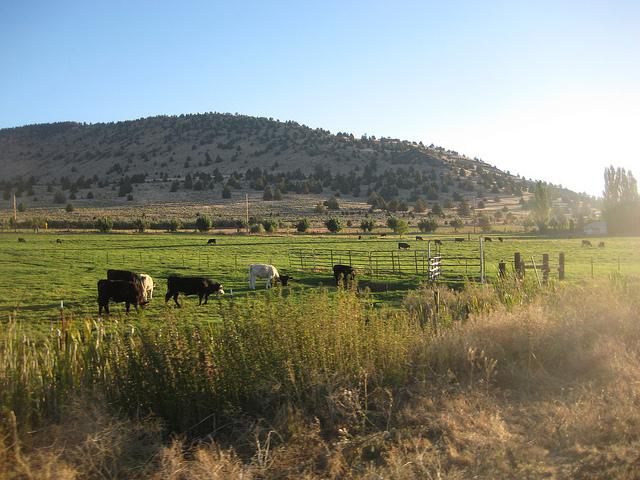Can you see the sun?
Give a very brief answer. No. How many cows are there?
Quick response, please. 5. Where is the fence?
Quick response, please. In field. What continent are these animals grazing on?
Concise answer only. North america. What type of animal is in the field?
Concise answer only. Cow. What type of landscape are the animals standing in?
Write a very short answer. Field. 